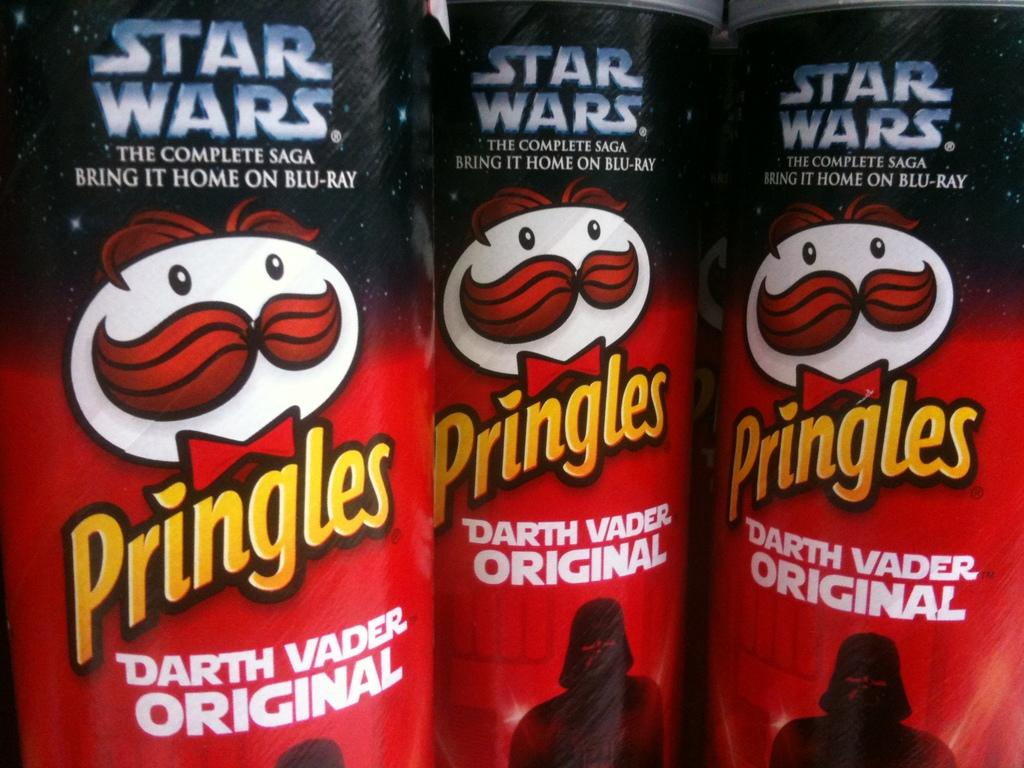<image>
Summarize the visual content of the image. Three cans of Star Wars edition original Pringles. 